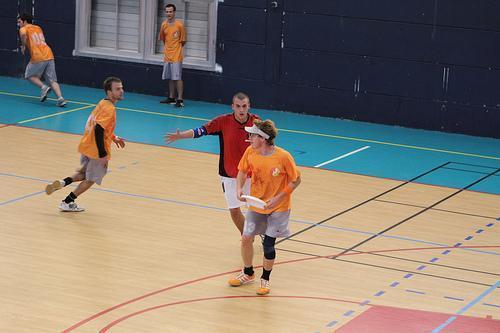How many people on the court are in orange?
Give a very brief answer. 2. 